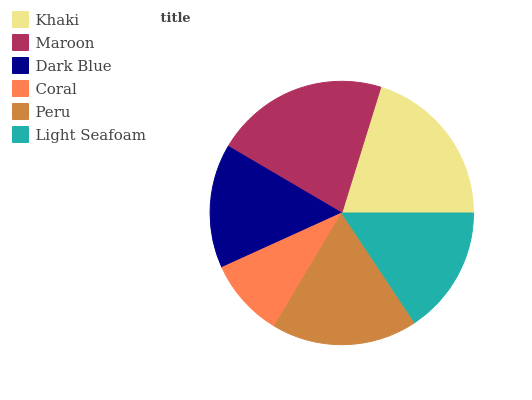Is Coral the minimum?
Answer yes or no. Yes. Is Maroon the maximum?
Answer yes or no. Yes. Is Dark Blue the minimum?
Answer yes or no. No. Is Dark Blue the maximum?
Answer yes or no. No. Is Maroon greater than Dark Blue?
Answer yes or no. Yes. Is Dark Blue less than Maroon?
Answer yes or no. Yes. Is Dark Blue greater than Maroon?
Answer yes or no. No. Is Maroon less than Dark Blue?
Answer yes or no. No. Is Peru the high median?
Answer yes or no. Yes. Is Light Seafoam the low median?
Answer yes or no. Yes. Is Dark Blue the high median?
Answer yes or no. No. Is Maroon the low median?
Answer yes or no. No. 